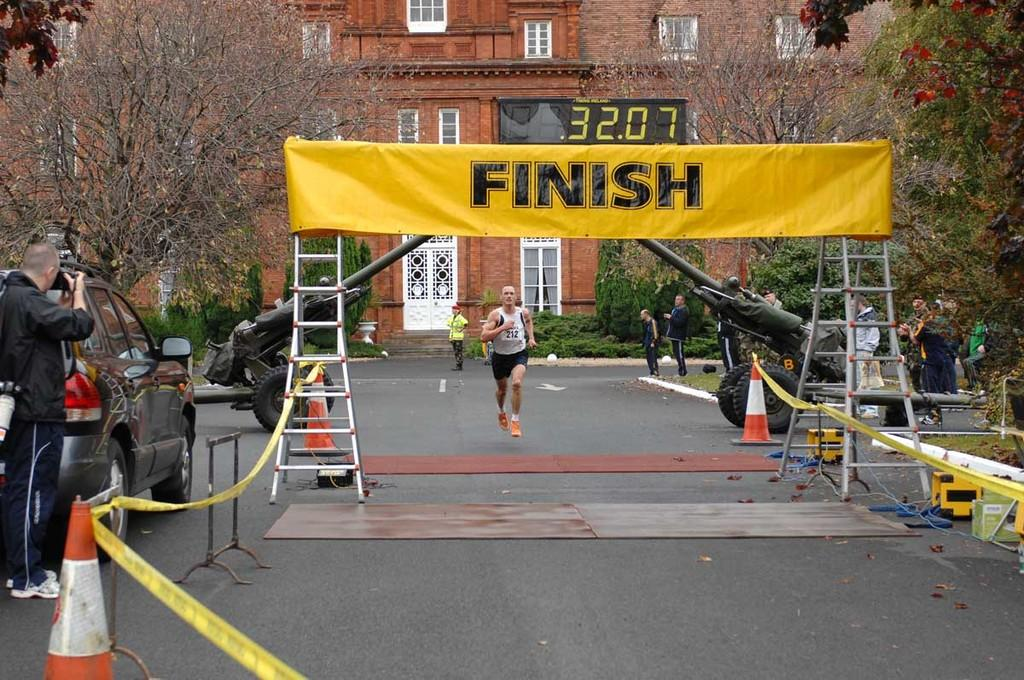<image>
Summarize the visual content of the image. A large yellow banner that says "FINISH" hangs above the road indicating the end of the race 